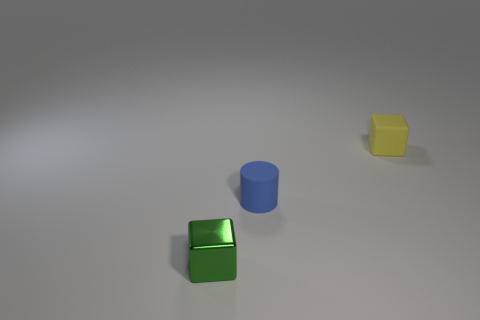The blue thing that is the same material as the small yellow object is what size?
Offer a terse response. Small. What number of matte objects have the same color as the shiny object?
Make the answer very short. 0. Are there fewer yellow objects that are in front of the small blue matte cylinder than tiny green objects left of the green thing?
Give a very brief answer. No. What size is the block to the right of the small green block?
Offer a very short reply. Small. Are there any green things that have the same material as the blue thing?
Offer a very short reply. No. Is the material of the green block the same as the yellow thing?
Offer a very short reply. No. Are there the same number of tiny blue rubber objects and big cyan balls?
Provide a short and direct response. No. There is a rubber block that is the same size as the metallic block; what color is it?
Offer a terse response. Yellow. How many other things are there of the same shape as the small green object?
Your response must be concise. 1. There is a metal object; is it the same size as the matte object in front of the tiny rubber cube?
Keep it short and to the point. Yes. 